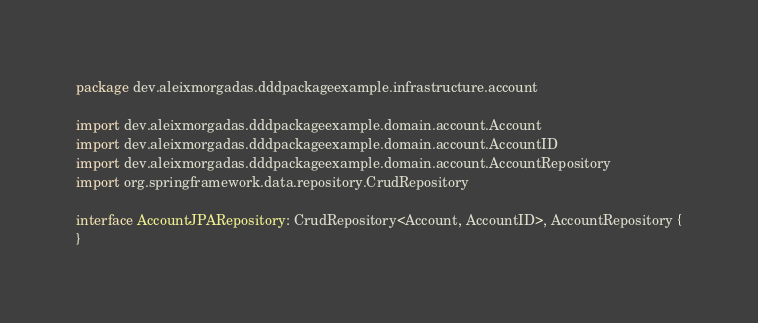<code> <loc_0><loc_0><loc_500><loc_500><_Kotlin_>package dev.aleixmorgadas.dddpackageexample.infrastructure.account

import dev.aleixmorgadas.dddpackageexample.domain.account.Account
import dev.aleixmorgadas.dddpackageexample.domain.account.AccountID
import dev.aleixmorgadas.dddpackageexample.domain.account.AccountRepository
import org.springframework.data.repository.CrudRepository

interface AccountJPARepository: CrudRepository<Account, AccountID>, AccountRepository {
}</code> 